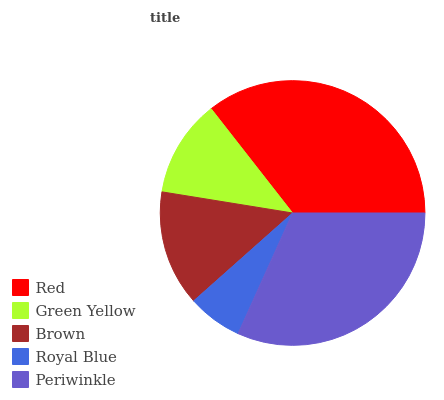Is Royal Blue the minimum?
Answer yes or no. Yes. Is Red the maximum?
Answer yes or no. Yes. Is Green Yellow the minimum?
Answer yes or no. No. Is Green Yellow the maximum?
Answer yes or no. No. Is Red greater than Green Yellow?
Answer yes or no. Yes. Is Green Yellow less than Red?
Answer yes or no. Yes. Is Green Yellow greater than Red?
Answer yes or no. No. Is Red less than Green Yellow?
Answer yes or no. No. Is Brown the high median?
Answer yes or no. Yes. Is Brown the low median?
Answer yes or no. Yes. Is Green Yellow the high median?
Answer yes or no. No. Is Periwinkle the low median?
Answer yes or no. No. 